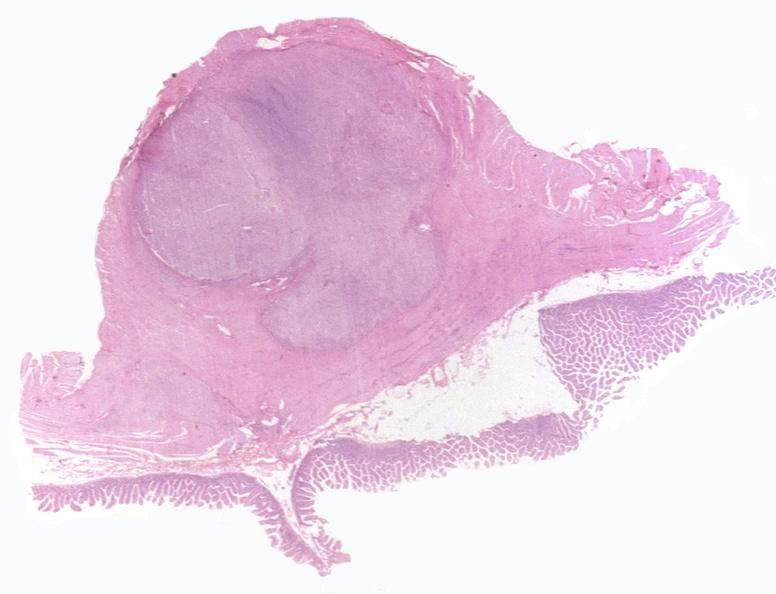s eosinophilic adenoma present?
Answer the question using a single word or phrase. No 